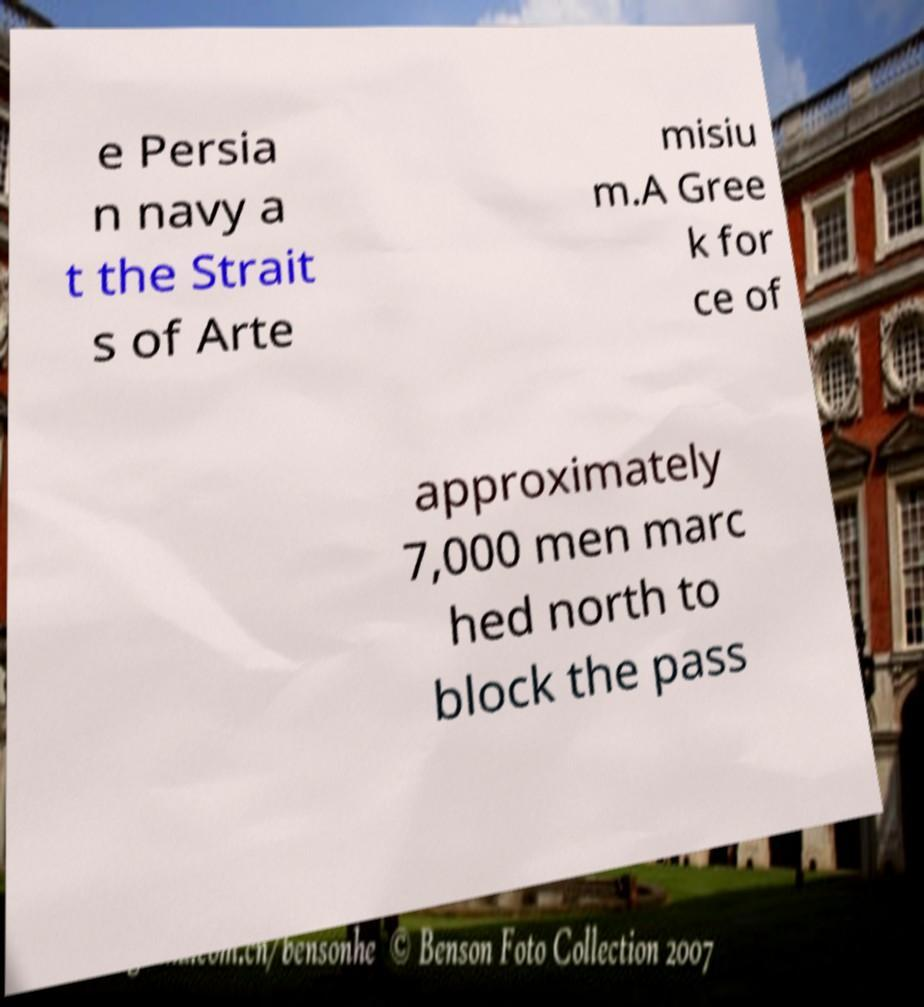I need the written content from this picture converted into text. Can you do that? e Persia n navy a t the Strait s of Arte misiu m.A Gree k for ce of approximately 7,000 men marc hed north to block the pass 